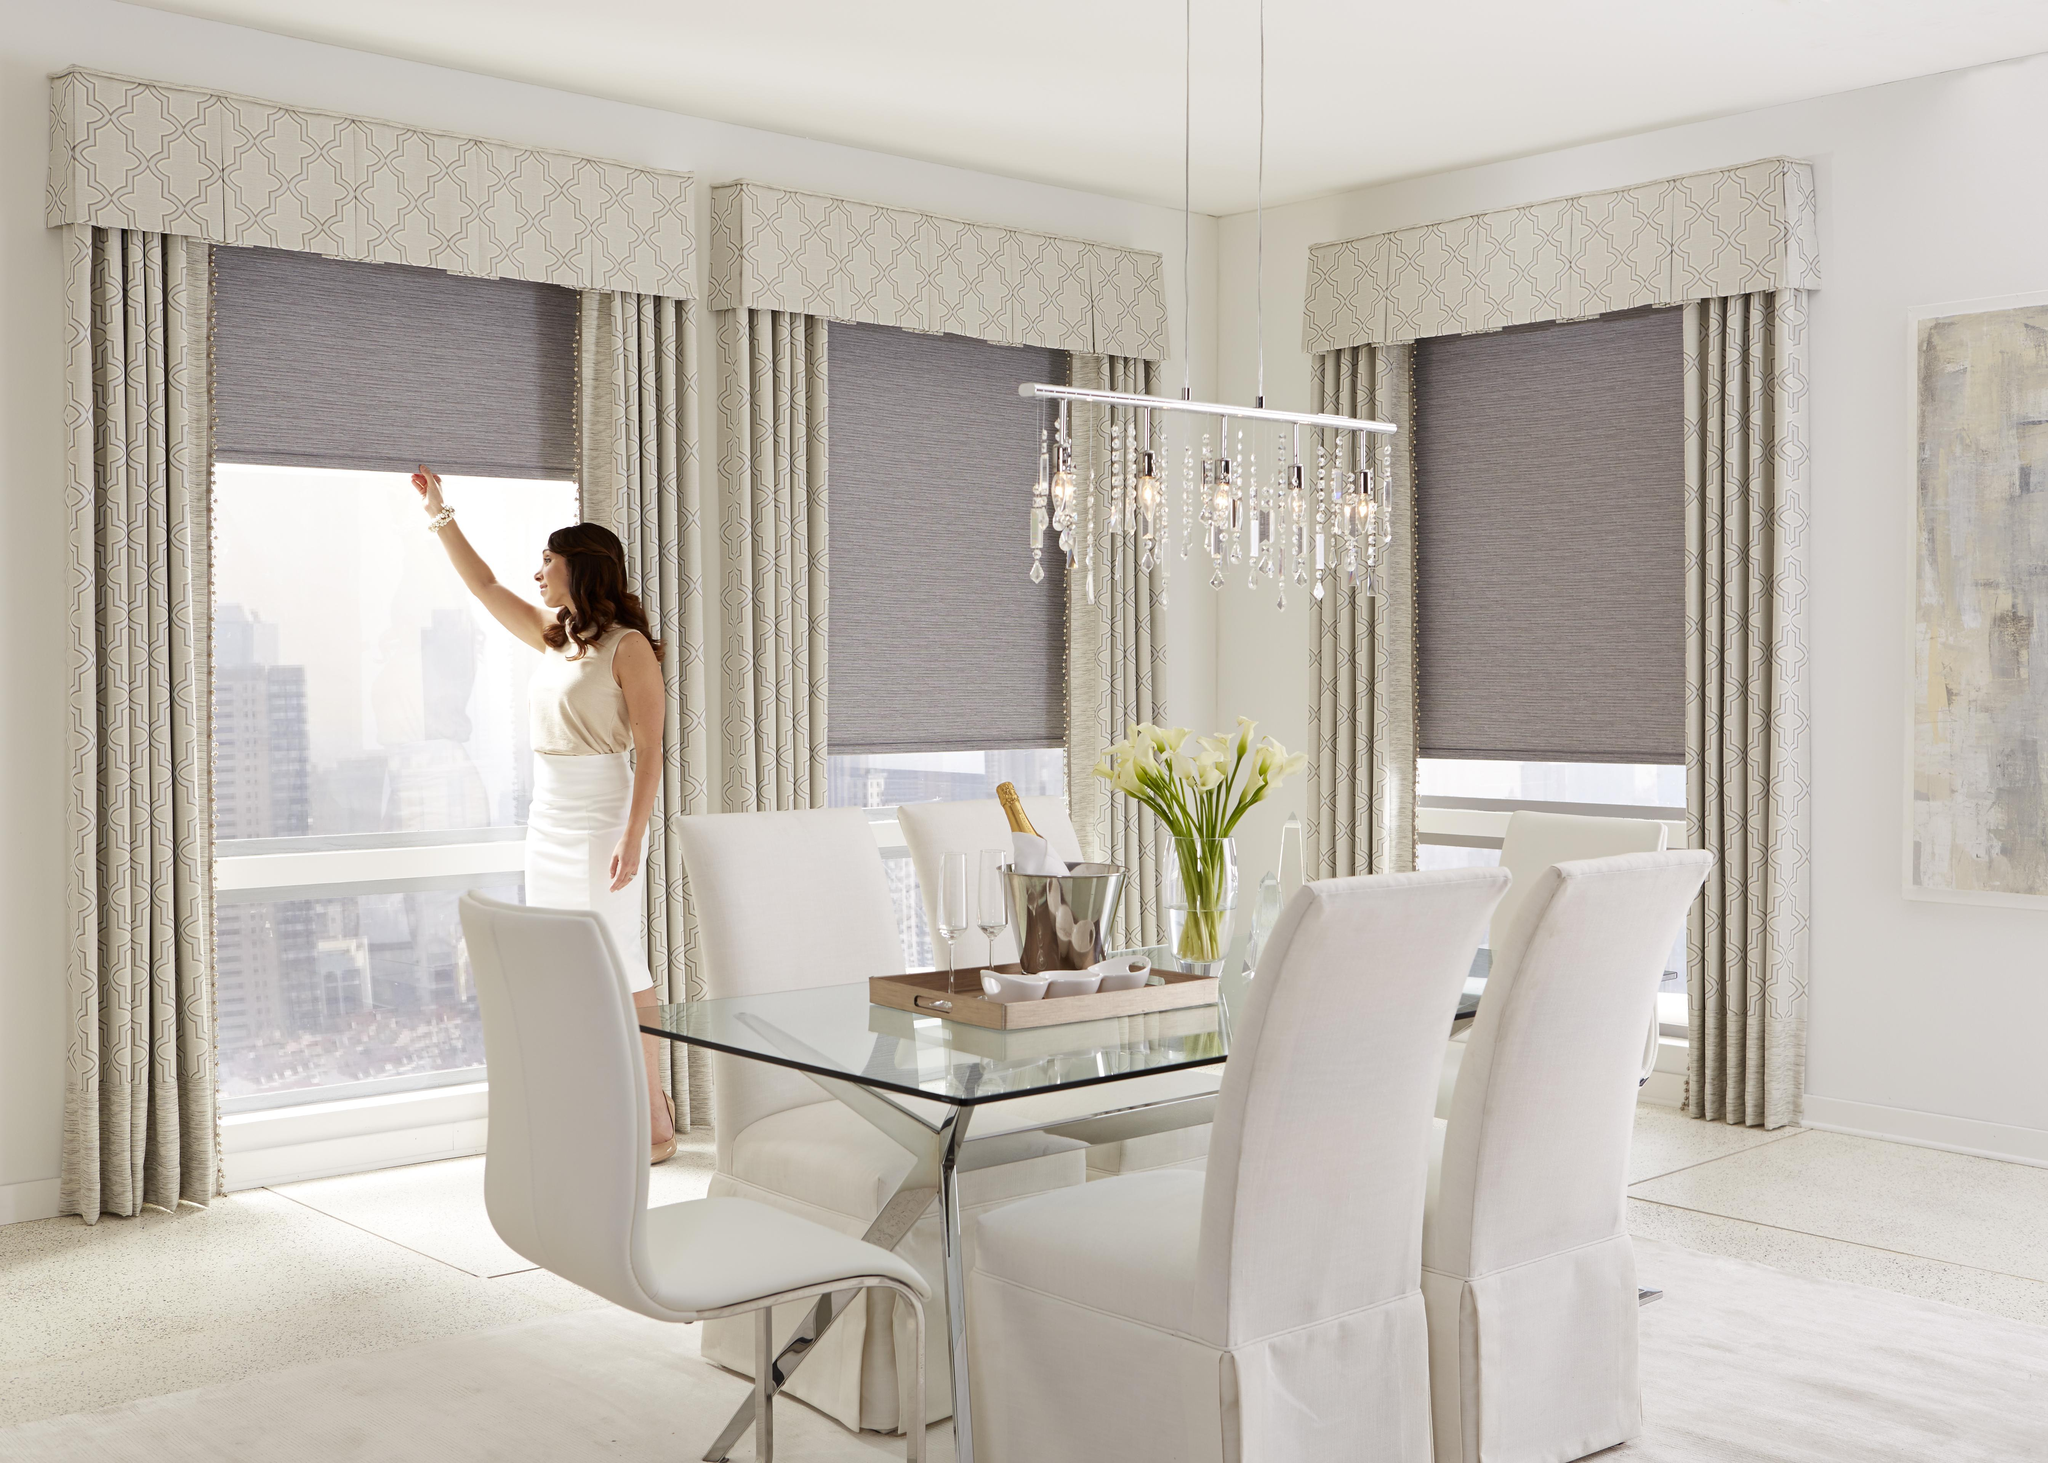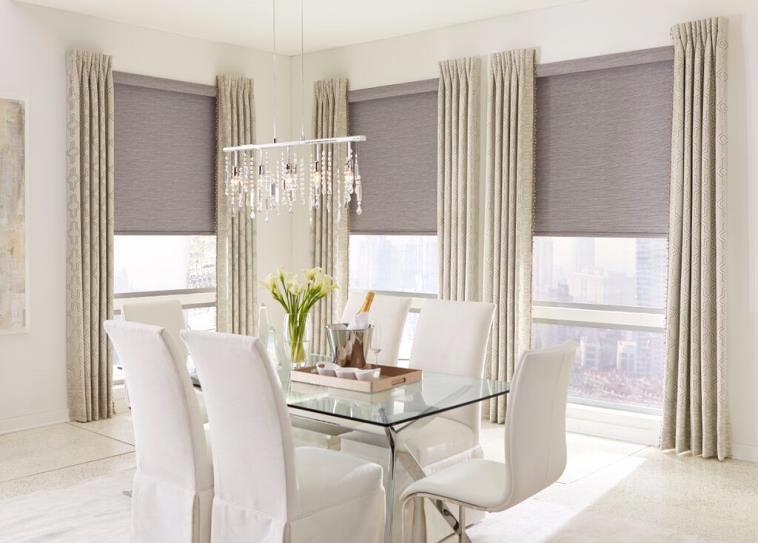The first image is the image on the left, the second image is the image on the right. Considering the images on both sides, is "An image shows a chandelier over a table and chairs in front of a corner with a total of three tall windows hung with solid-colored drapes in front of shades pulled half-way down." valid? Answer yes or no. Yes. The first image is the image on the left, the second image is the image on the right. Analyze the images presented: Is the assertion "There are three partially open shades in the right image." valid? Answer yes or no. Yes. 